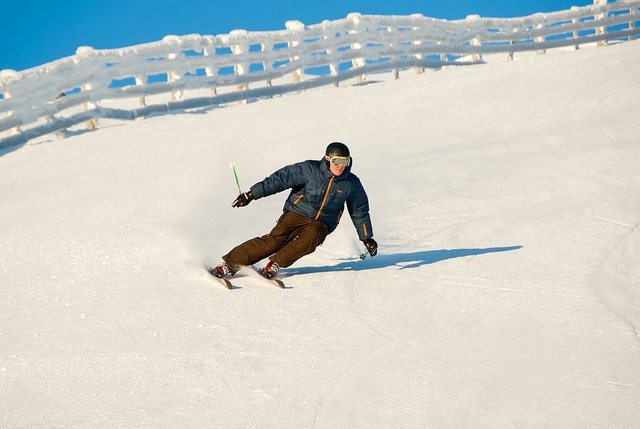Describe the objects in this image and their specific colors. I can see people in teal, black, maroon, purple, and blue tones and skis in teal, gray, darkgray, and tan tones in this image. 